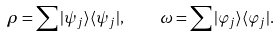<formula> <loc_0><loc_0><loc_500><loc_500>\rho = \sum | \psi _ { j } \rangle \langle \psi _ { j } | , \quad \omega = \sum | \varphi _ { j } \rangle \langle \varphi _ { j } | .</formula> 